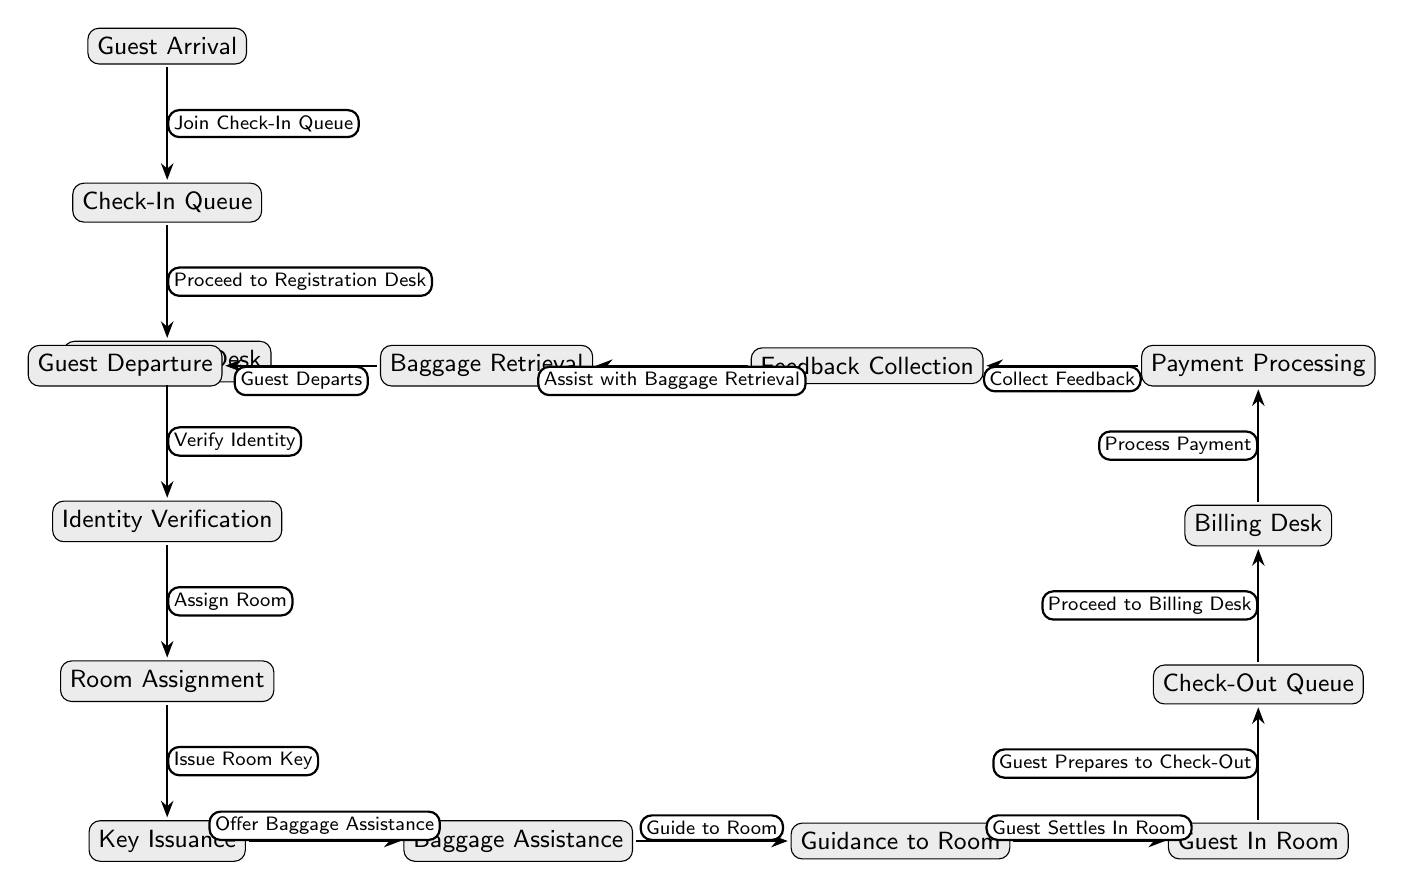What is the first step in the guest check-in process? The diagram indicates that the first step is "Guest Arrival," which is the initial node in the flow.
Answer: Guest Arrival How many main steps are there in the check-in process? The diagram shows six main steps leading from "Guest Arrival" to "Key Issuance." The steps are clearly listed, so counting them gives a total of six.
Answer: 6 What does the guest do after receiving their room key? According to the diagram, after receiving the room key, the guest is offered "Baggage Assistance," which follows as the next step.
Answer: Offer Baggage Assistance What happens before "Payment Processing" in the check-out process? The diagram shows that "Proceed to Billing Desk" must occur before "Payment Processing," clearly indicating a sequential flow where billing comes first.
Answer: Proceed to Billing Desk Which two processes are linked directly to "Guest In Room"? The diagram shows that "Guest Prepares to Check-Out" and "Guide to Room" are both linked to the "Guest In Room" step, reflecting a flow that supports the check-out preparation as well as the guidance to the guest's room.
Answer: Guest Prepares to Check-Out and Guide to Room After "Collect Feedback," what is the next action in the check-out process? The diagram indicates that immediately after "Collect Feedback," the next action is "Assist with Baggage Retrieval," highlighting a sequence of activities that follow the feedback collection.
Answer: Assist with Baggage Retrieval What node comes after "Identity Verification"? In the flow of the check-in process, the node following "Identity Verification" is "Room Assignment," indicating the progression from verifying identity to assigning the room.
Answer: Room Assignment How many steps are there from "Check-In Queue" to "Key Issuance"? By examining the diagram, the flow from "Check-In Queue" to "Key Issuance" includes four steps: "Proceed to Registration Desk," "Verify Identity," "Assign Room," and "Issue Room Key." Counting these gives a total of four steps.
Answer: 4 